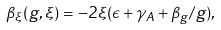<formula> <loc_0><loc_0><loc_500><loc_500>\beta _ { \xi } ( g , \xi ) = - 2 \xi ( \epsilon + \gamma _ { A } + \beta _ { g } / g ) ,</formula> 